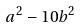<formula> <loc_0><loc_0><loc_500><loc_500>a ^ { 2 } - 1 0 b ^ { 2 }</formula> 